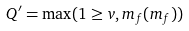Convert formula to latex. <formula><loc_0><loc_0><loc_500><loc_500>Q ^ { \prime } = \max ( 1 \geq v , m _ { f } ( m _ { f } ) )</formula> 